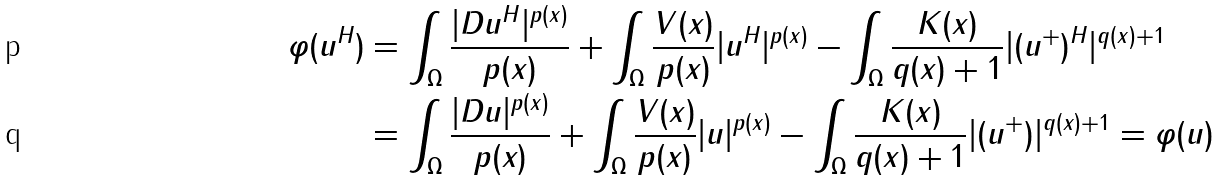Convert formula to latex. <formula><loc_0><loc_0><loc_500><loc_500>\varphi ( u ^ { H } ) & = \int _ { \Omega } \frac { | D u ^ { H } | ^ { p ( x ) } } { p ( x ) } + \int _ { \Omega } \frac { V ( x ) } { p ( x ) } | u ^ { H } | ^ { p ( x ) } - \int _ { \Omega } \frac { K ( x ) } { q ( x ) + 1 } | ( u ^ { + } ) ^ { H } | ^ { q ( x ) + 1 } \\ & = \int _ { \Omega } \frac { | D u | ^ { p ( x ) } } { p ( x ) } + \int _ { \Omega } \frac { V ( x ) } { p ( x ) } | u | ^ { p ( x ) } - \int _ { \Omega } \frac { K ( x ) } { q ( x ) + 1 } | ( u ^ { + } ) | ^ { q ( x ) + 1 } = \varphi ( u )</formula> 